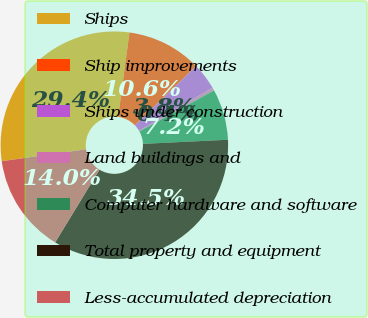<chart> <loc_0><loc_0><loc_500><loc_500><pie_chart><fcel>Ships<fcel>Ship improvements<fcel>Ships under construction<fcel>Land buildings and<fcel>Computer hardware and software<fcel>Total property and equipment<fcel>Less-accumulated depreciation<nl><fcel>29.37%<fcel>10.64%<fcel>3.82%<fcel>0.42%<fcel>7.23%<fcel>34.48%<fcel>14.04%<nl></chart> 